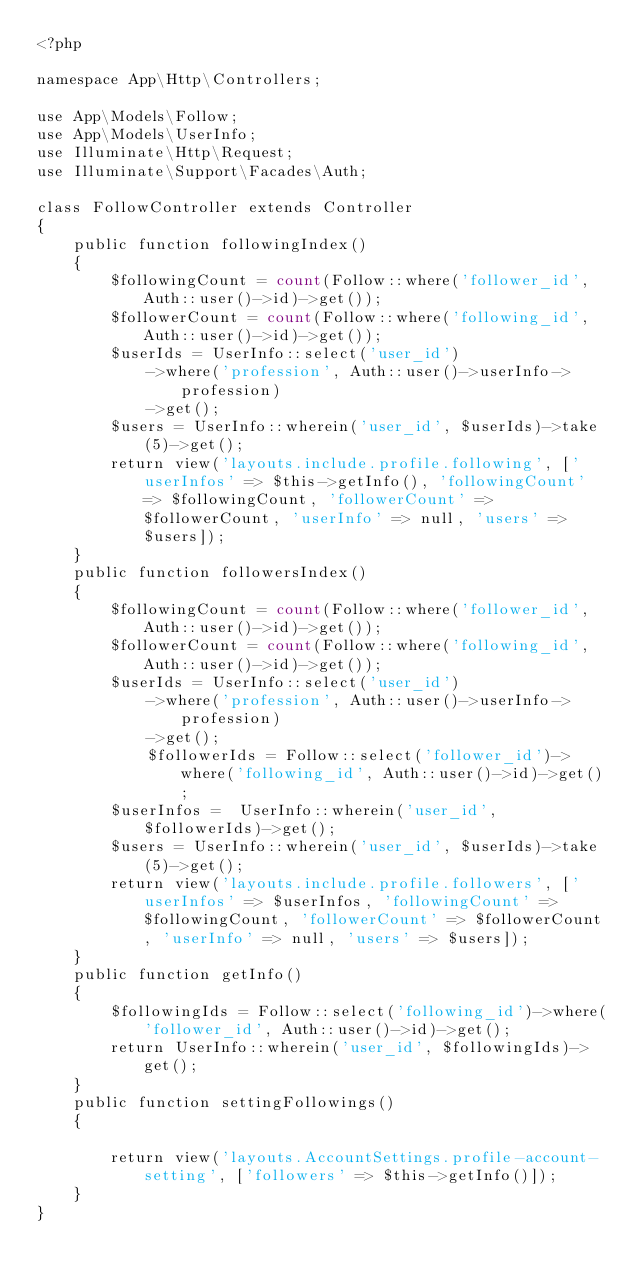Convert code to text. <code><loc_0><loc_0><loc_500><loc_500><_PHP_><?php

namespace App\Http\Controllers;

use App\Models\Follow;
use App\Models\UserInfo;
use Illuminate\Http\Request;
use Illuminate\Support\Facades\Auth;

class FollowController extends Controller
{
    public function followingIndex()
    {
        $followingCount = count(Follow::where('follower_id', Auth::user()->id)->get());
        $followerCount = count(Follow::where('following_id', Auth::user()->id)->get());
        $userIds = UserInfo::select('user_id')
            ->where('profession', Auth::user()->userInfo->profession)
            ->get();
        $users = UserInfo::wherein('user_id', $userIds)->take(5)->get();
        return view('layouts.include.profile.following', ['userInfos' => $this->getInfo(), 'followingCount' => $followingCount, 'followerCount' => $followerCount, 'userInfo' => null, 'users' => $users]);
    }
    public function followersIndex()
    {
        $followingCount = count(Follow::where('follower_id', Auth::user()->id)->get());
        $followerCount = count(Follow::where('following_id', Auth::user()->id)->get());
        $userIds = UserInfo::select('user_id')
            ->where('profession', Auth::user()->userInfo->profession)
            ->get();
            $followerIds = Follow::select('follower_id')->where('following_id', Auth::user()->id)->get();
        $userInfos =  UserInfo::wherein('user_id', $followerIds)->get();
        $users = UserInfo::wherein('user_id', $userIds)->take(5)->get();
        return view('layouts.include.profile.followers', ['userInfos' => $userInfos, 'followingCount' => $followingCount, 'followerCount' => $followerCount, 'userInfo' => null, 'users' => $users]);
    }
    public function getInfo()
    {
        $followingIds = Follow::select('following_id')->where('follower_id', Auth::user()->id)->get();
        return UserInfo::wherein('user_id', $followingIds)->get();
    }
    public function settingFollowings()
    {

        return view('layouts.AccountSettings.profile-account-setting', ['followers' => $this->getInfo()]);
    }
}
</code> 